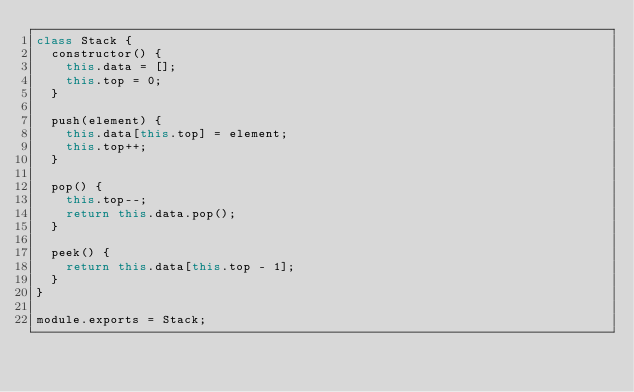<code> <loc_0><loc_0><loc_500><loc_500><_JavaScript_>class Stack {
  constructor() {
    this.data = [];
    this.top = 0;
  }

  push(element) {
    this.data[this.top] = element;
    this.top++;
  }

  pop() {
    this.top--;
    return this.data.pop();
  }

  peek() {
    return this.data[this.top - 1];
  }
}

module.exports = Stack;
</code> 